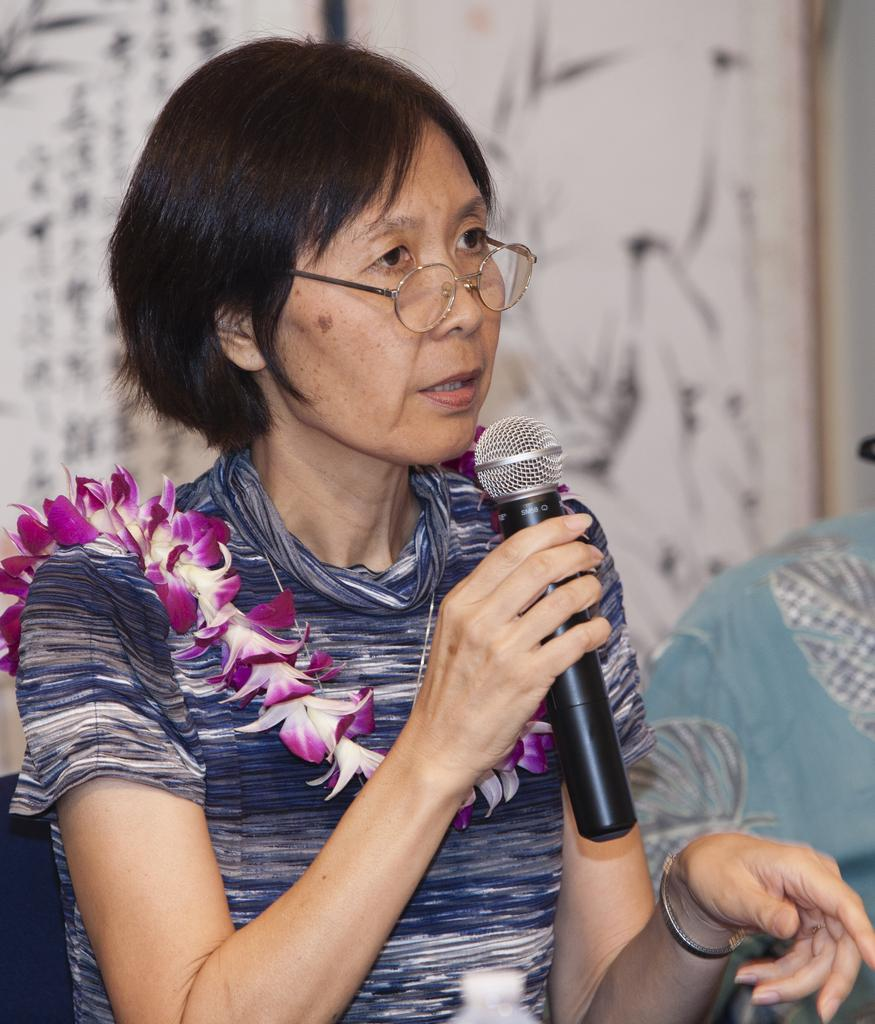Who is the main subject in the image? There is a woman in the image. What is the woman holding in the image? The woman is holding a microphone. What is the woman doing in the image? The woman is talking. What type of salt can be seen on the woman's hands in the image? There is no salt visible on the woman's hands in the image. 